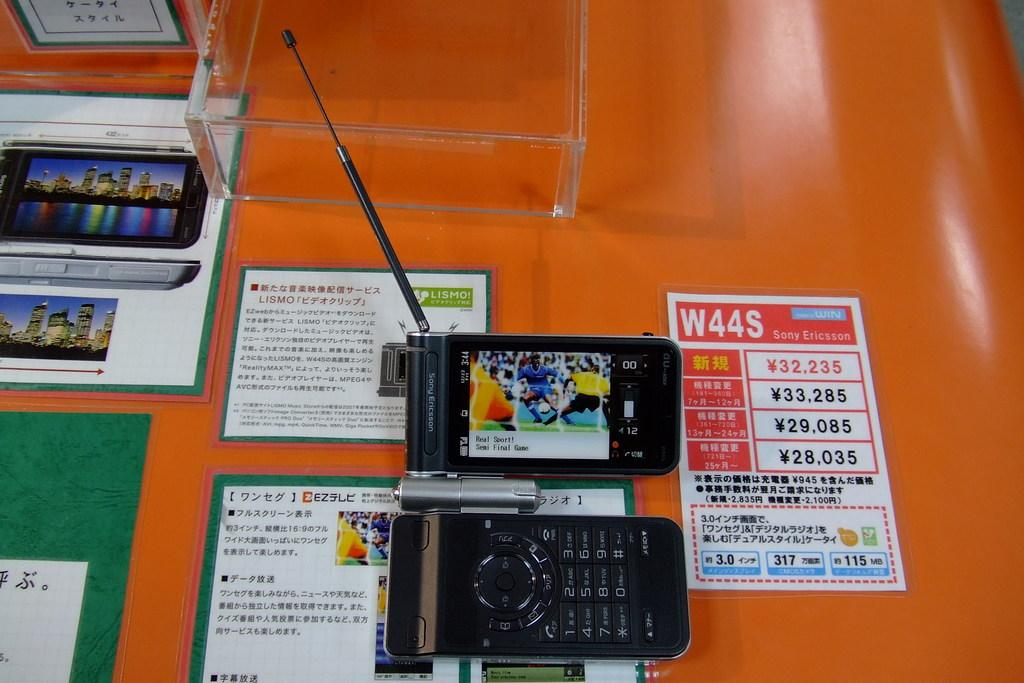Provide a one-sentence caption for the provided image. a sony erickson device next to another phone. 